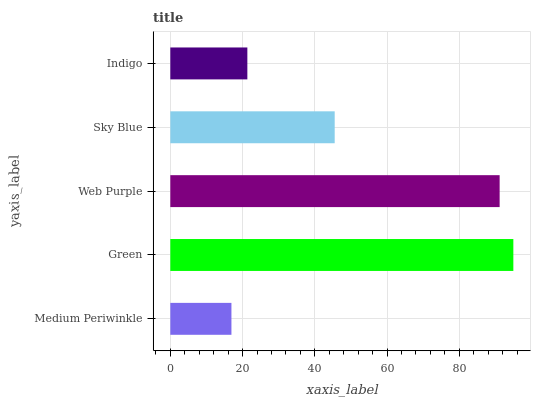Is Medium Periwinkle the minimum?
Answer yes or no. Yes. Is Green the maximum?
Answer yes or no. Yes. Is Web Purple the minimum?
Answer yes or no. No. Is Web Purple the maximum?
Answer yes or no. No. Is Green greater than Web Purple?
Answer yes or no. Yes. Is Web Purple less than Green?
Answer yes or no. Yes. Is Web Purple greater than Green?
Answer yes or no. No. Is Green less than Web Purple?
Answer yes or no. No. Is Sky Blue the high median?
Answer yes or no. Yes. Is Sky Blue the low median?
Answer yes or no. Yes. Is Indigo the high median?
Answer yes or no. No. Is Indigo the low median?
Answer yes or no. No. 